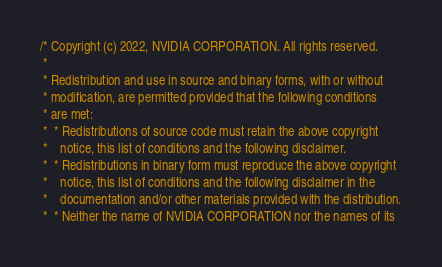<code> <loc_0><loc_0><loc_500><loc_500><_Cuda_>/* Copyright (c) 2022, NVIDIA CORPORATION. All rights reserved.
 *
 * Redistribution and use in source and binary forms, with or without
 * modification, are permitted provided that the following conditions
 * are met:
 *  * Redistributions of source code must retain the above copyright
 *    notice, this list of conditions and the following disclaimer.
 *  * Redistributions in binary form must reproduce the above copyright
 *    notice, this list of conditions and the following disclaimer in the
 *    documentation and/or other materials provided with the distribution.
 *  * Neither the name of NVIDIA CORPORATION nor the names of its</code> 